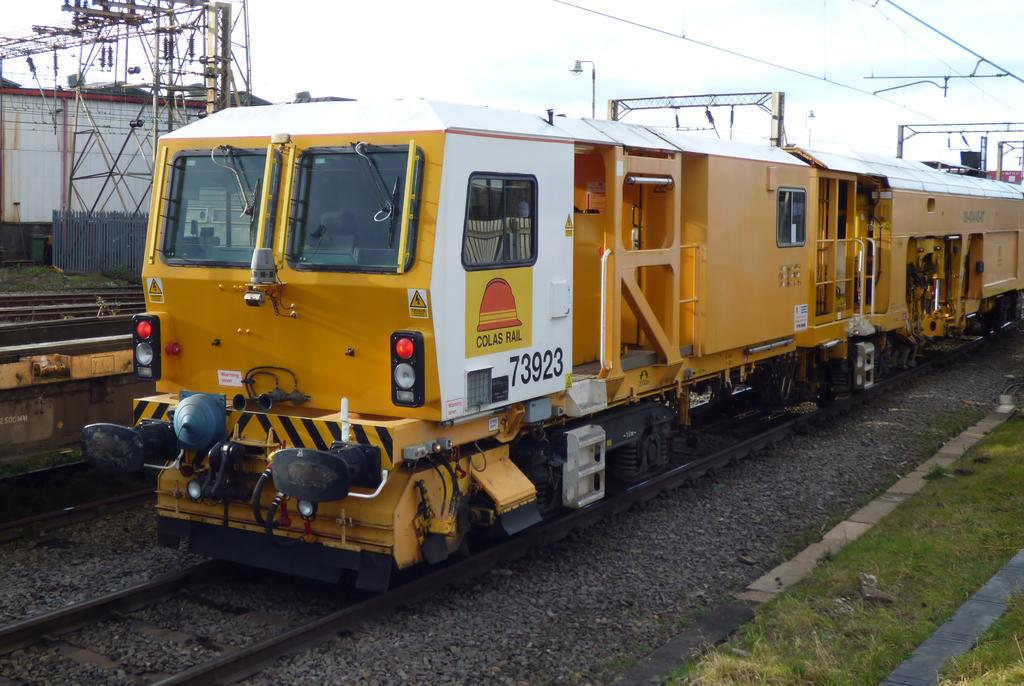What type of vegetation is present in the image? There is grass in the image. What mode of transportation can be seen in the image? There is a train on the tracks in the image. What can be seen in the background of the image? There are poles, cables, and a fence in the background of the image. Can you see a record player in the image? There is no record player present in the image. Is there a deer visible in the image? There is no deer present in the image. 